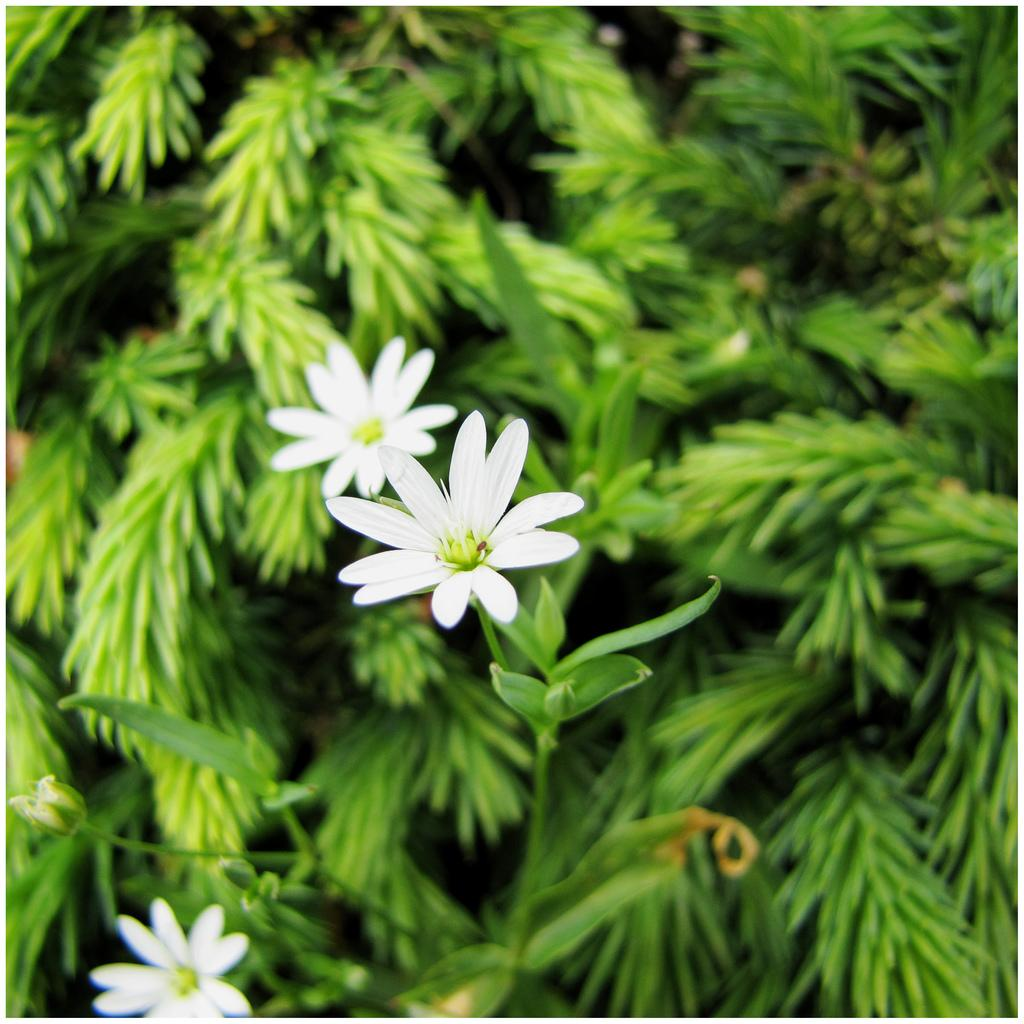What type of plants can be seen in the image? There are flowers and green leaves in the image. Can you describe the color of the flowers? The provided facts do not mention the color of the flowers, so we cannot definitively answer that question. How many jellyfish can be seen swimming on the roof in the image? There are no jellyfish or roof present in the image; it features flowers and green leaves. 